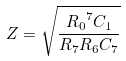<formula> <loc_0><loc_0><loc_500><loc_500>Z = \sqrt { \frac { { R _ { 0 } } ^ { 7 } C _ { 1 } } { R _ { 7 } R _ { 6 } C _ { 7 } } }</formula> 